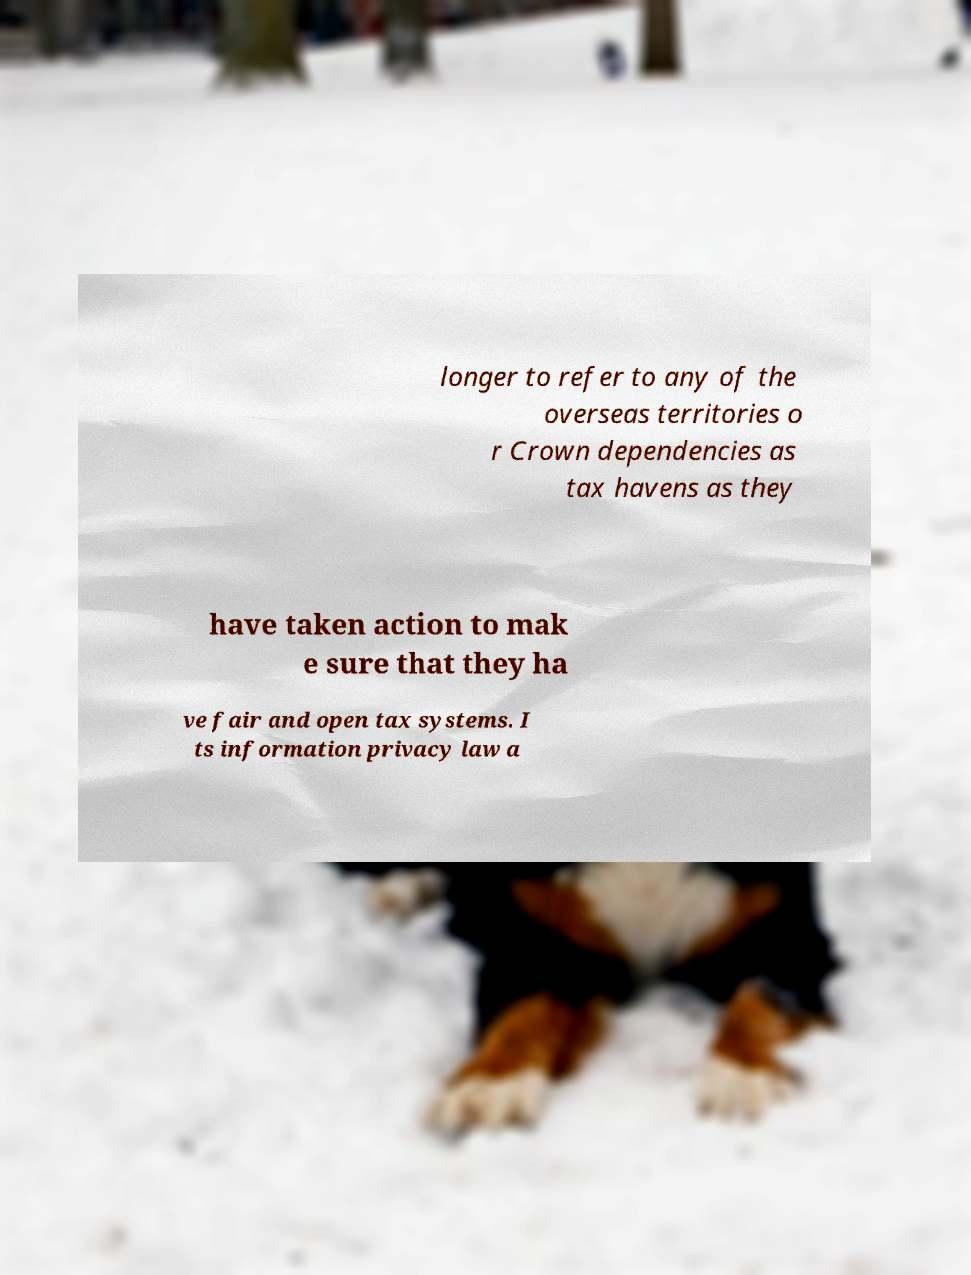For documentation purposes, I need the text within this image transcribed. Could you provide that? longer to refer to any of the overseas territories o r Crown dependencies as tax havens as they have taken action to mak e sure that they ha ve fair and open tax systems. I ts information privacy law a 